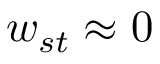Convert formula to latex. <formula><loc_0><loc_0><loc_500><loc_500>w _ { s t } \approx 0</formula> 